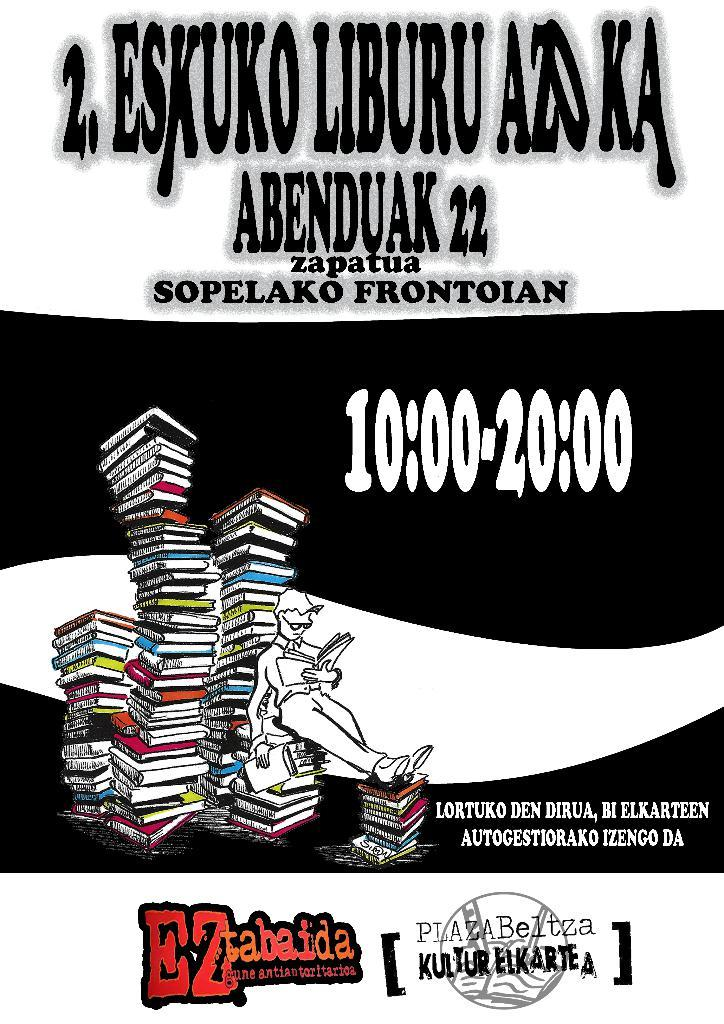What is the person in the image doing? The person is holding a book in the image. What else can be seen related to books in the image? There is a group of books in the image. Can you describe any text visible in the image? Yes, there is text visible in the image. What type of scarf is the person wearing in the image? There is no scarf visible in the image; the person is holding a book. Is the person sleeping in the image? The person is holding a book in the image, and there is no indication that they are sleeping. 